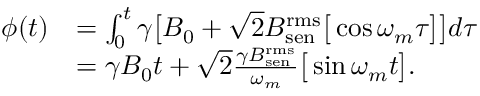Convert formula to latex. <formula><loc_0><loc_0><loc_500><loc_500>\begin{array} { r l } { \phi ( t ) } & { = \int _ { 0 } ^ { t } \gamma \left [ B _ { 0 } + \sqrt { 2 } B _ { s e n } ^ { r m s } \left [ \cos \omega _ { m } \tau \right ] \right ] d \tau } \\ & { = \gamma B _ { 0 } t + \sqrt { 2 } \frac { \gamma B _ { s e n } ^ { r m s } } { \omega _ { m } } \left [ \sin \omega _ { m } t \right ] . } \end{array}</formula> 